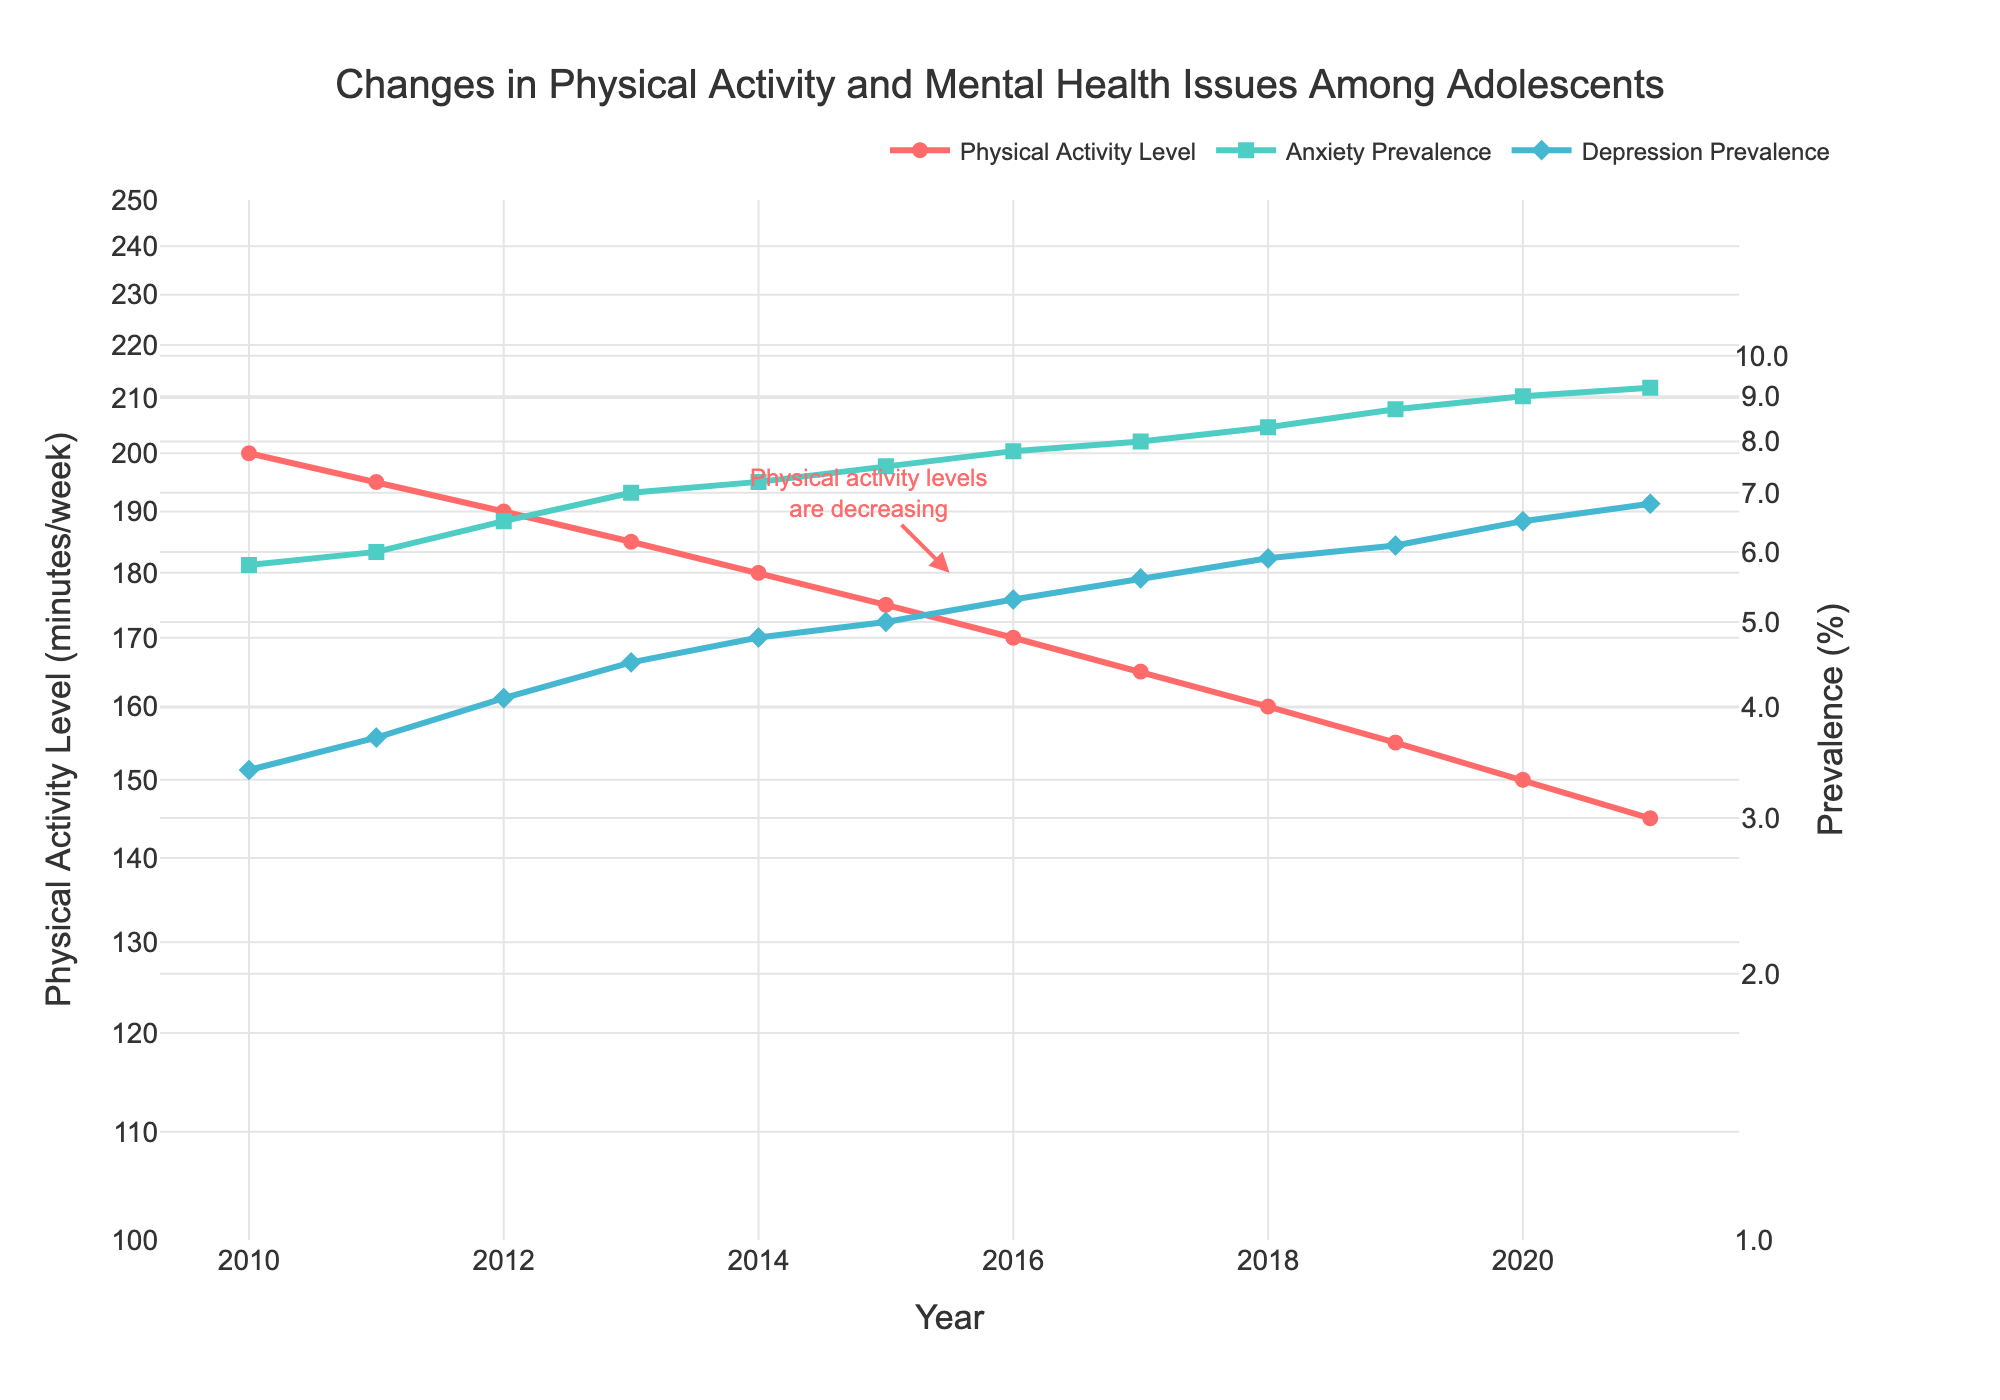what is the title of the figure? Look at the top of the figure to find the text indicating what the overall chart is about.
Answer: Changes in Physical Activity and Mental Health Issues Among Adolescents How many data points are there for physical activity levels? Count the number of points or markers present in the line representing physical activity levels.
Answer: 12 Which year had the highest prevalence of anxiety? Identify the highest point on the anxiety prevalence line and note its corresponding year on the x-axis.
Answer: 2021 By how much did the physical activity levels decrease from 2010 to 2021? Subtract the physical activity level in 2021 from the level in 2010 (200 - 145 = 55).
Answer: 55 In which year did depression prevalence exceed 5%? Locate the point on the line representing depression prevalence that first goes above the 5% mark and note the corresponding year on the x-axis.
Answer: 2015 Compare the trend in physical activity levels with anxiety prevalence over the years. Observe the general direction of the lines for both physical activity and anxiety prevalence from 2010 to 2021. Physical activity levels are consistently decreasing while anxiety prevalence is consistently increasing.
Answer: Decreasing vs. Increasing What is the numerical range for the y-axis representing physical activity levels? Check the minimum and maximum values indicated on the primary y-axis (log scale).
Answer: 100 to 250 What annotation is connected to the point around the year 2015.5 on the anxiety prevalence line? Look for the text explanation or note attached to the data point around 2015.5 on the anxiety prevalence line.
Answer: Mental health issues are increasing Estimate the physical activity level in 2015 based on the graph. Find the data point for the year 2015 on the physical activity level line, use the position on the y-axis to estimate the value close to 175.
Answer: 175 What could be inferred about mental health issues if the trend of physical activity continues as shown? Analyze the pattern: Since decreasing physical activity correlates with increasing anxiety and depression, continued decline in physical activity likely suggests further increases in mental health issues.
Answer: Increasing 